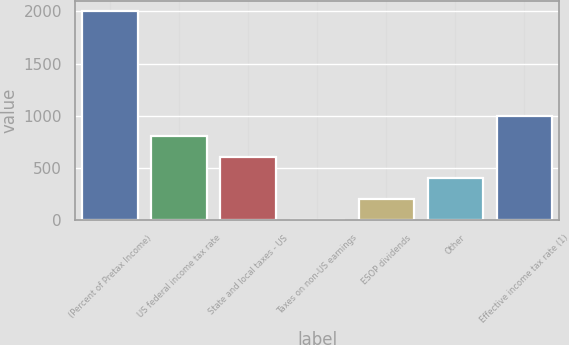Convert chart to OTSL. <chart><loc_0><loc_0><loc_500><loc_500><bar_chart><fcel>(Percent of Pretax Income)<fcel>US federal income tax rate<fcel>State and local taxes - US<fcel>Taxes on non-US earnings<fcel>ESOP dividends<fcel>Other<fcel>Effective income tax rate (1)<nl><fcel>2002<fcel>801.44<fcel>601.35<fcel>1.08<fcel>201.17<fcel>401.26<fcel>1001.53<nl></chart> 